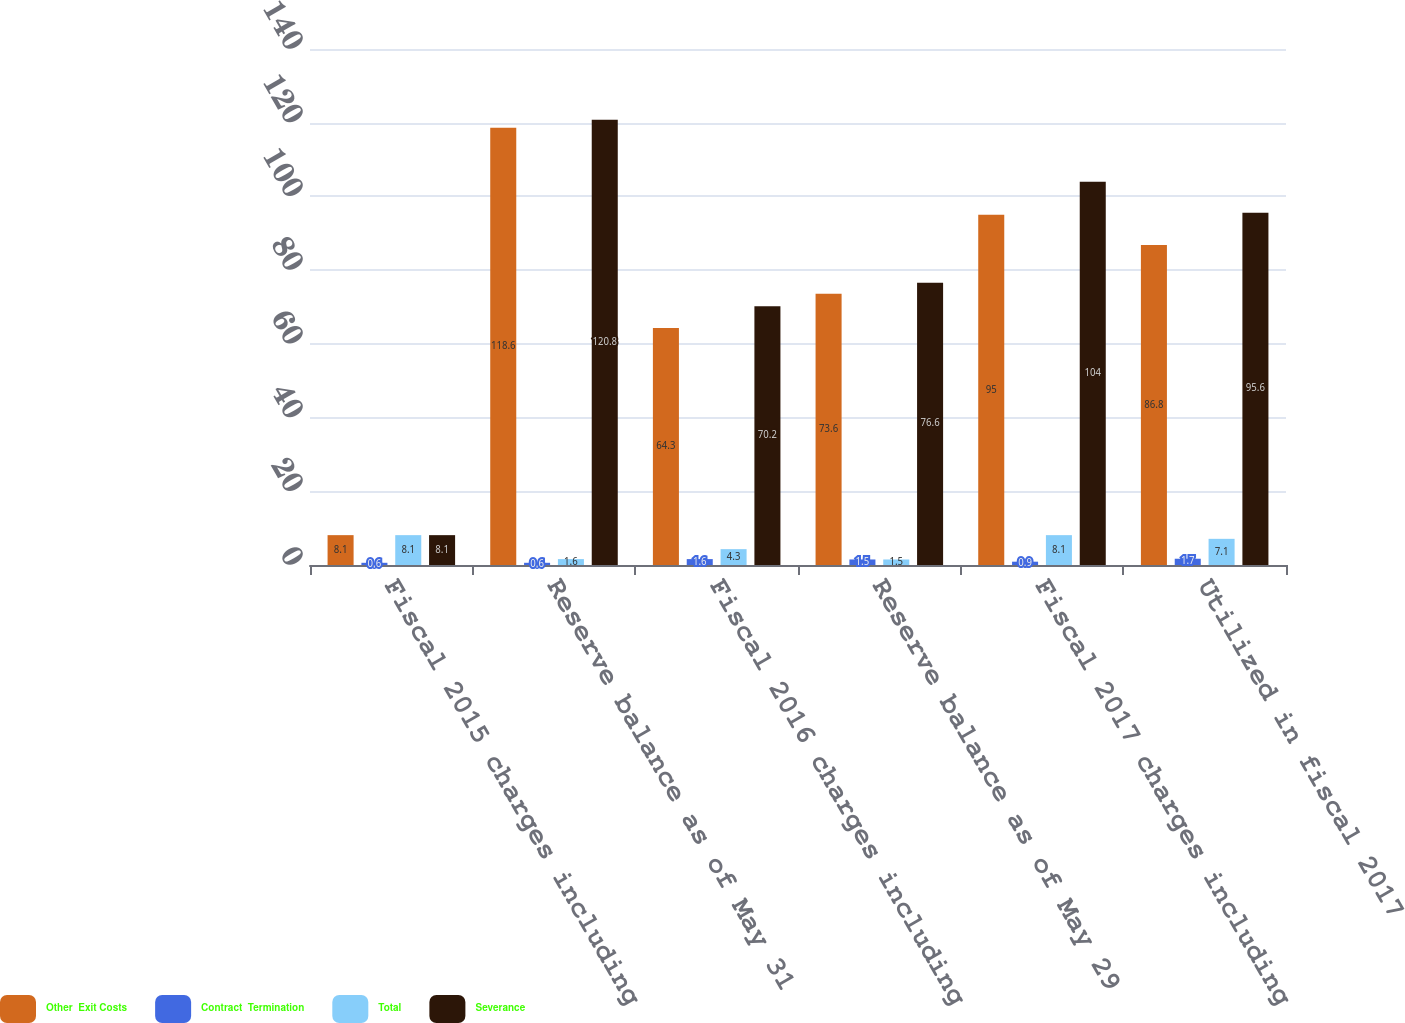Convert chart to OTSL. <chart><loc_0><loc_0><loc_500><loc_500><stacked_bar_chart><ecel><fcel>Fiscal 2015 charges including<fcel>Reserve balance as of May 31<fcel>Fiscal 2016 charges including<fcel>Reserve balance as of May 29<fcel>Fiscal 2017 charges including<fcel>Utilized in fiscal 2017<nl><fcel>Other  Exit Costs<fcel>8.1<fcel>118.6<fcel>64.3<fcel>73.6<fcel>95<fcel>86.8<nl><fcel>Contract  Termination<fcel>0.6<fcel>0.6<fcel>1.6<fcel>1.5<fcel>0.9<fcel>1.7<nl><fcel>Total<fcel>8.1<fcel>1.6<fcel>4.3<fcel>1.5<fcel>8.1<fcel>7.1<nl><fcel>Severance<fcel>8.1<fcel>120.8<fcel>70.2<fcel>76.6<fcel>104<fcel>95.6<nl></chart> 